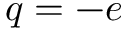Convert formula to latex. <formula><loc_0><loc_0><loc_500><loc_500>q = - e</formula> 